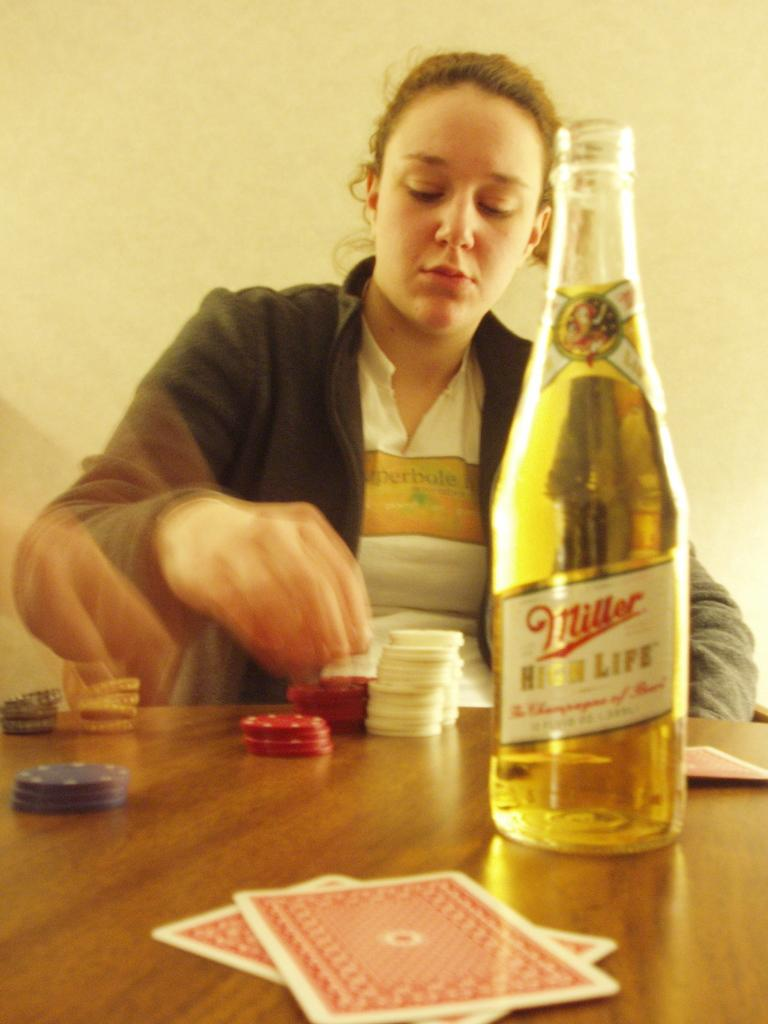<image>
Present a compact description of the photo's key features. A woman sit a table with a bottle of Miller beer in front of her. 